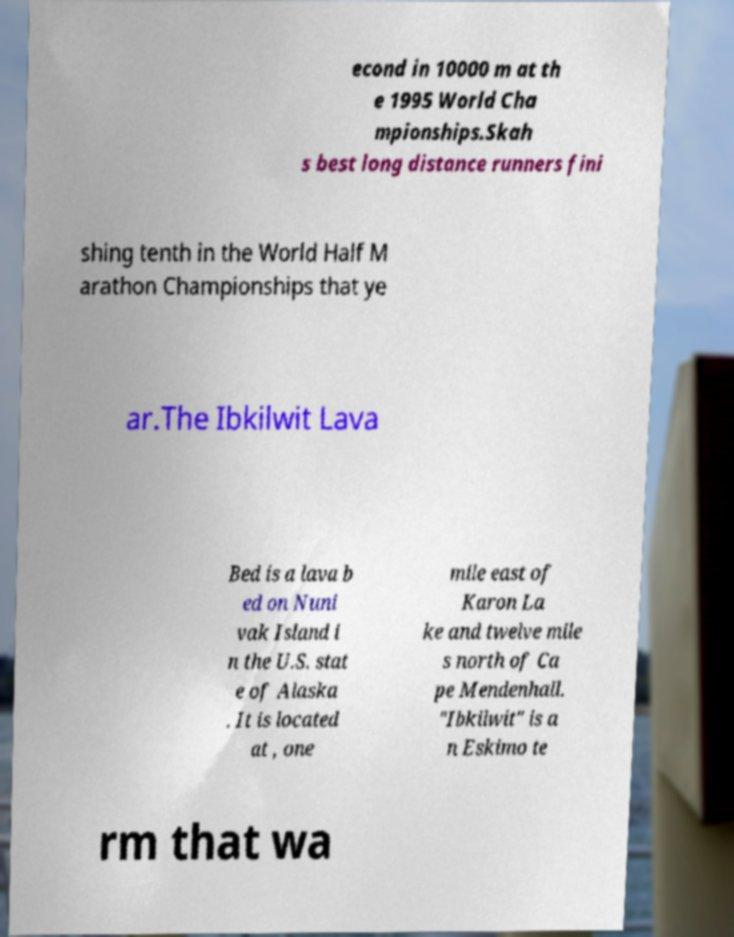Can you read and provide the text displayed in the image?This photo seems to have some interesting text. Can you extract and type it out for me? econd in 10000 m at th e 1995 World Cha mpionships.Skah s best long distance runners fini shing tenth in the World Half M arathon Championships that ye ar.The Ibkilwit Lava Bed is a lava b ed on Nuni vak Island i n the U.S. stat e of Alaska . It is located at , one mile east of Karon La ke and twelve mile s north of Ca pe Mendenhall. "Ibkilwit" is a n Eskimo te rm that wa 